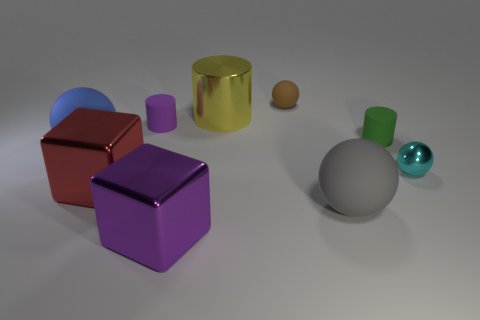What is the shape of the gray object to the left of the metallic object on the right side of the brown matte object? sphere 